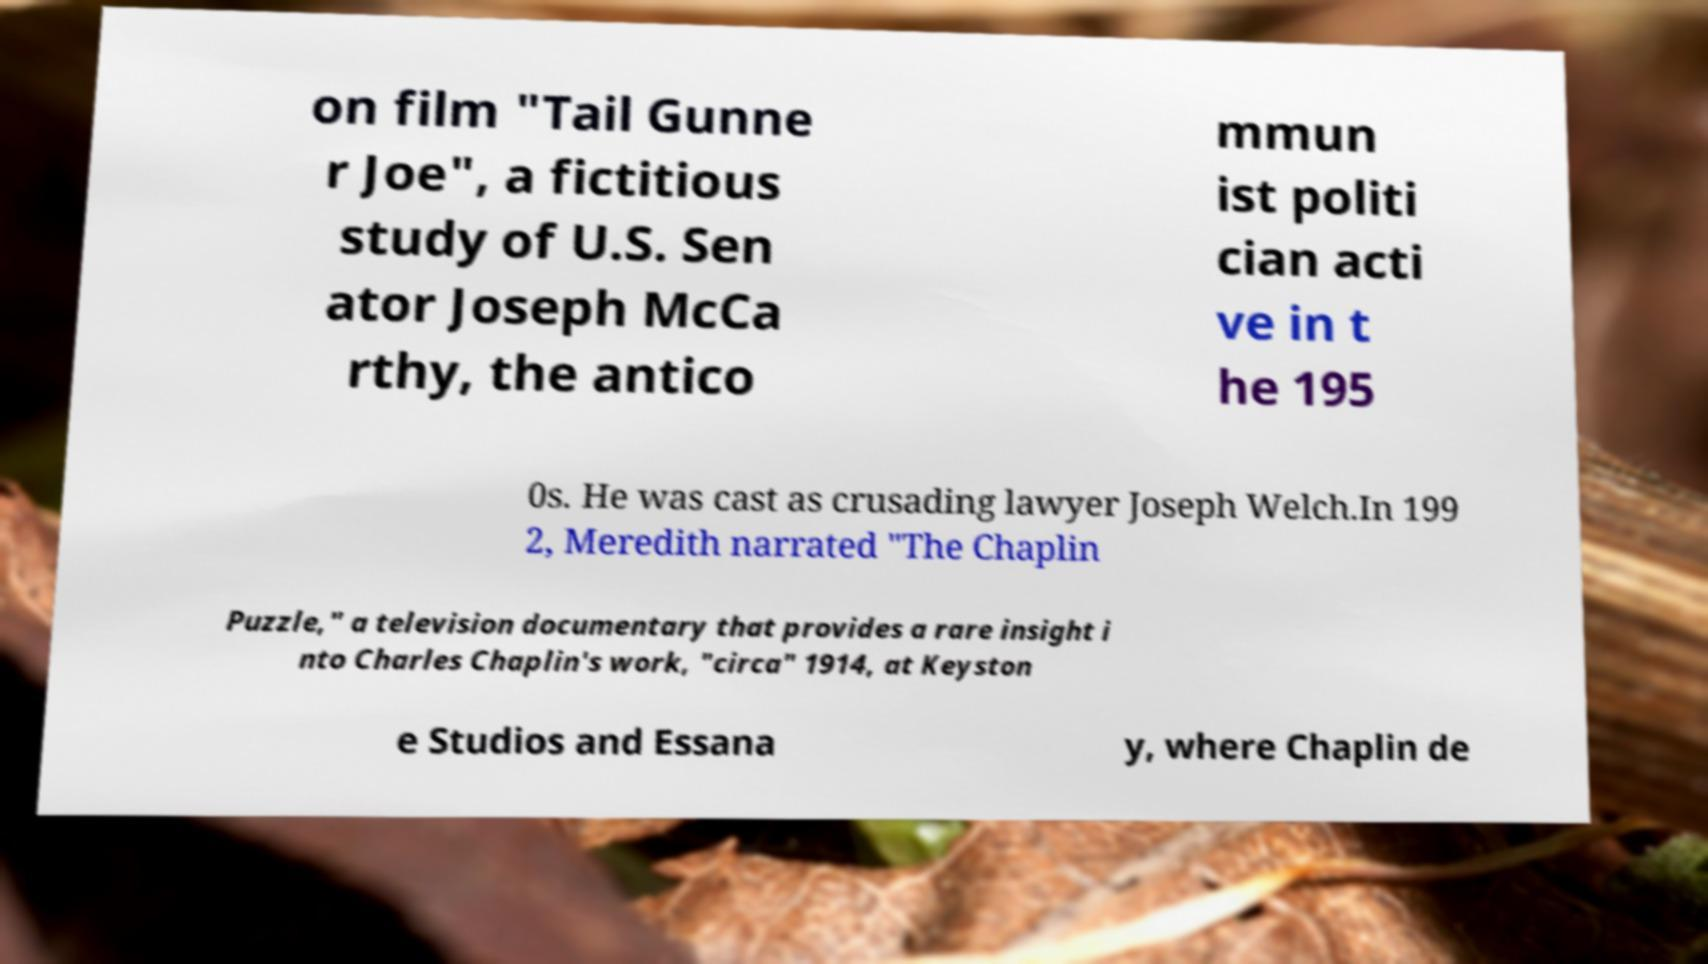There's text embedded in this image that I need extracted. Can you transcribe it verbatim? on film "Tail Gunne r Joe", a fictitious study of U.S. Sen ator Joseph McCa rthy, the antico mmun ist politi cian acti ve in t he 195 0s. He was cast as crusading lawyer Joseph Welch.In 199 2, Meredith narrated "The Chaplin Puzzle," a television documentary that provides a rare insight i nto Charles Chaplin's work, "circa" 1914, at Keyston e Studios and Essana y, where Chaplin de 